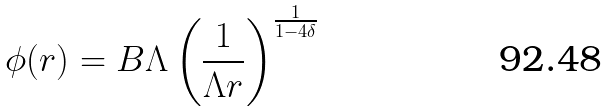<formula> <loc_0><loc_0><loc_500><loc_500>\phi ( r ) = B \Lambda \left ( \frac { 1 } { \Lambda r } \right ) ^ { \frac { 1 } { 1 - 4 \delta } }</formula> 